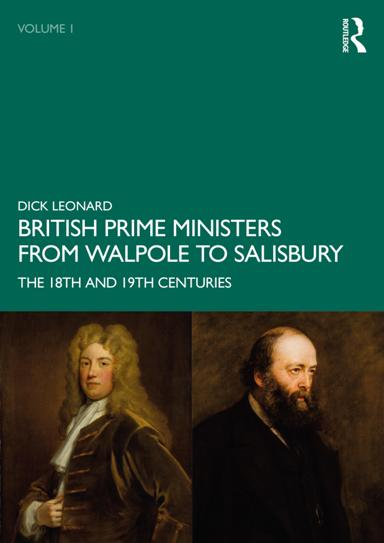What book is mentioned in the image? The image features the book titled "British Prime Ministers From Walpole to Salisbury: The 18th and 19th Centuries" authored by R. Dick Leonard. This survey provides an extensive examination of influential British leadership across two critical centuries in British history. 